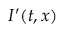<formula> <loc_0><loc_0><loc_500><loc_500>I ^ { \prime } ( t , x )</formula> 